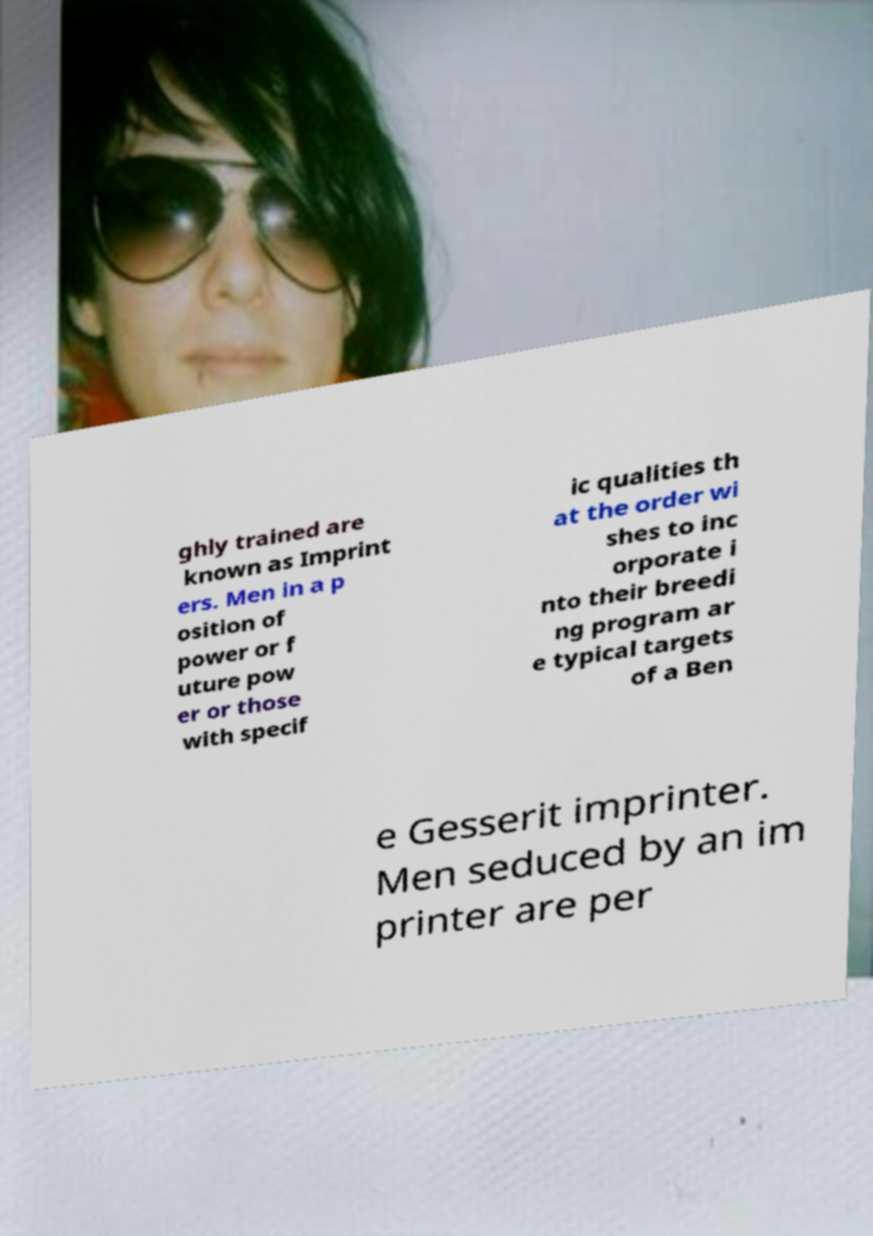Could you assist in decoding the text presented in this image and type it out clearly? ghly trained are known as Imprint ers. Men in a p osition of power or f uture pow er or those with specif ic qualities th at the order wi shes to inc orporate i nto their breedi ng program ar e typical targets of a Ben e Gesserit imprinter. Men seduced by an im printer are per 